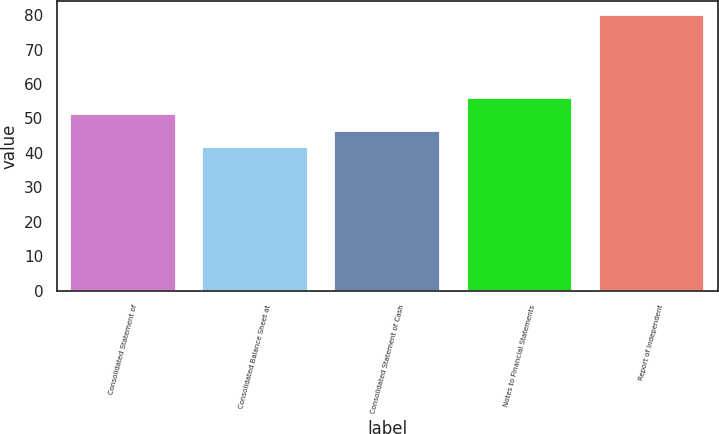<chart> <loc_0><loc_0><loc_500><loc_500><bar_chart><fcel>Consolidated Statement of<fcel>Consolidated Balance Sheet at<fcel>Consolidated Statement of Cash<fcel>Notes to Financial Statements<fcel>Report of Independent<nl><fcel>51.2<fcel>41.6<fcel>46.4<fcel>56<fcel>80<nl></chart> 